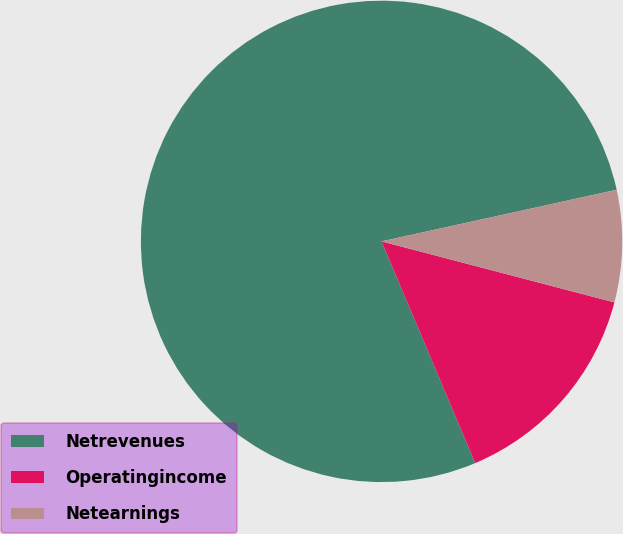Convert chart to OTSL. <chart><loc_0><loc_0><loc_500><loc_500><pie_chart><fcel>Netrevenues<fcel>Operatingincome<fcel>Netearnings<nl><fcel>77.92%<fcel>14.56%<fcel>7.52%<nl></chart> 